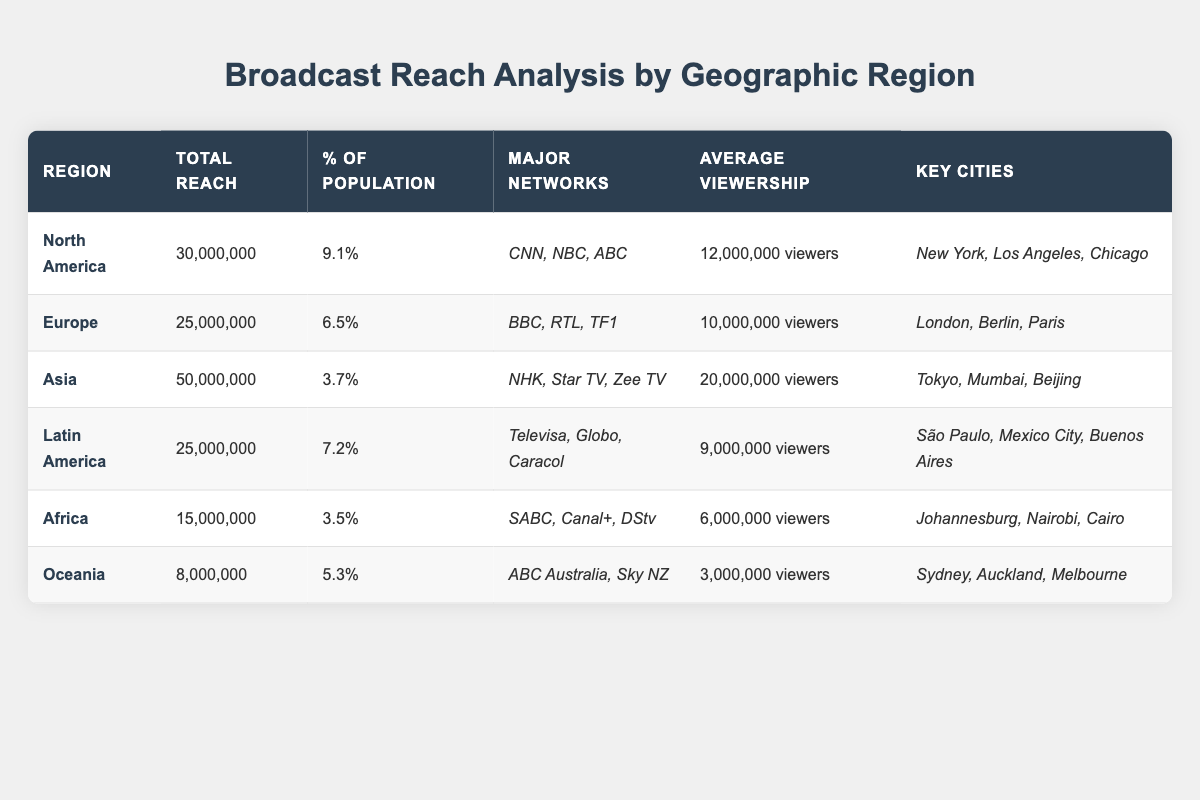What is the total reach in Asia? The table states that the total reach for Asia is 50,000,000.
Answer: 50,000,000 Which region has the highest average viewership? By comparing the average viewership of each region, Asia has the highest with 20,000,000 viewers.
Answer: Asia What percentage of the population does North America represent in terms of broadcast reach? The table indicates that North America has a percentage of 9.1% of the population.
Answer: 9.1% How many more viewers does North America have compared to Oceania? North America has 12,000,000 viewers and Oceania has 3,000,000 viewers. The difference is 12,000,000 - 3,000,000 = 9,000,000.
Answer: 9,000,000 Is the average viewership in Africa greater than that in Latin America? The average viewership in Africa is 6,000,000 while in Latin America it is 9,000,000. Since 6,000,000 is less than 9,000,000, the statement is false.
Answer: No What is the total reach of North America and Europe combined? Adding the total reach of North America (30,000,000) and Europe (25,000,000), we get 30,000,000 + 25,000,000 = 55,000,000.
Answer: 55,000,000 Which region has the lowest total reach and what is that value? The table shows that Oceania has the lowest total reach at 8,000,000.
Answer: Oceania, 8,000,000 Are there any regions where the percentage of the population that is reached exceeds 8%? According to the table, only North America exceeds 8% with 9.1%. Therefore, the answer is true for North America only.
Answer: Yes Which major networks are present in the Latin America region? The table specifies that the major networks for Latin America are Televisa, Globo, and Caracol.
Answer: Televisa, Globo, Caracol What is the average percentage of the population for all regions listed? The percentages of the population for each region are 9.1, 6.5, 3.7, 7.2, 3.5, and 5.3. Summing these gives 35.3, and dividing by 6 gives an average of approximately 5.88%.
Answer: Approximately 5.88% 